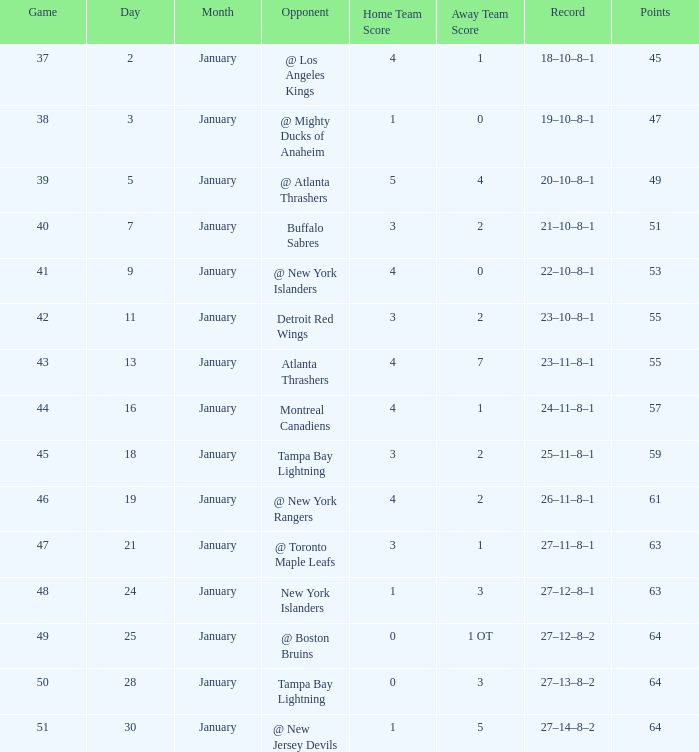Which points possess a score of 4-1, a record of 18-10-8-1, and a january greater than 2? None. 